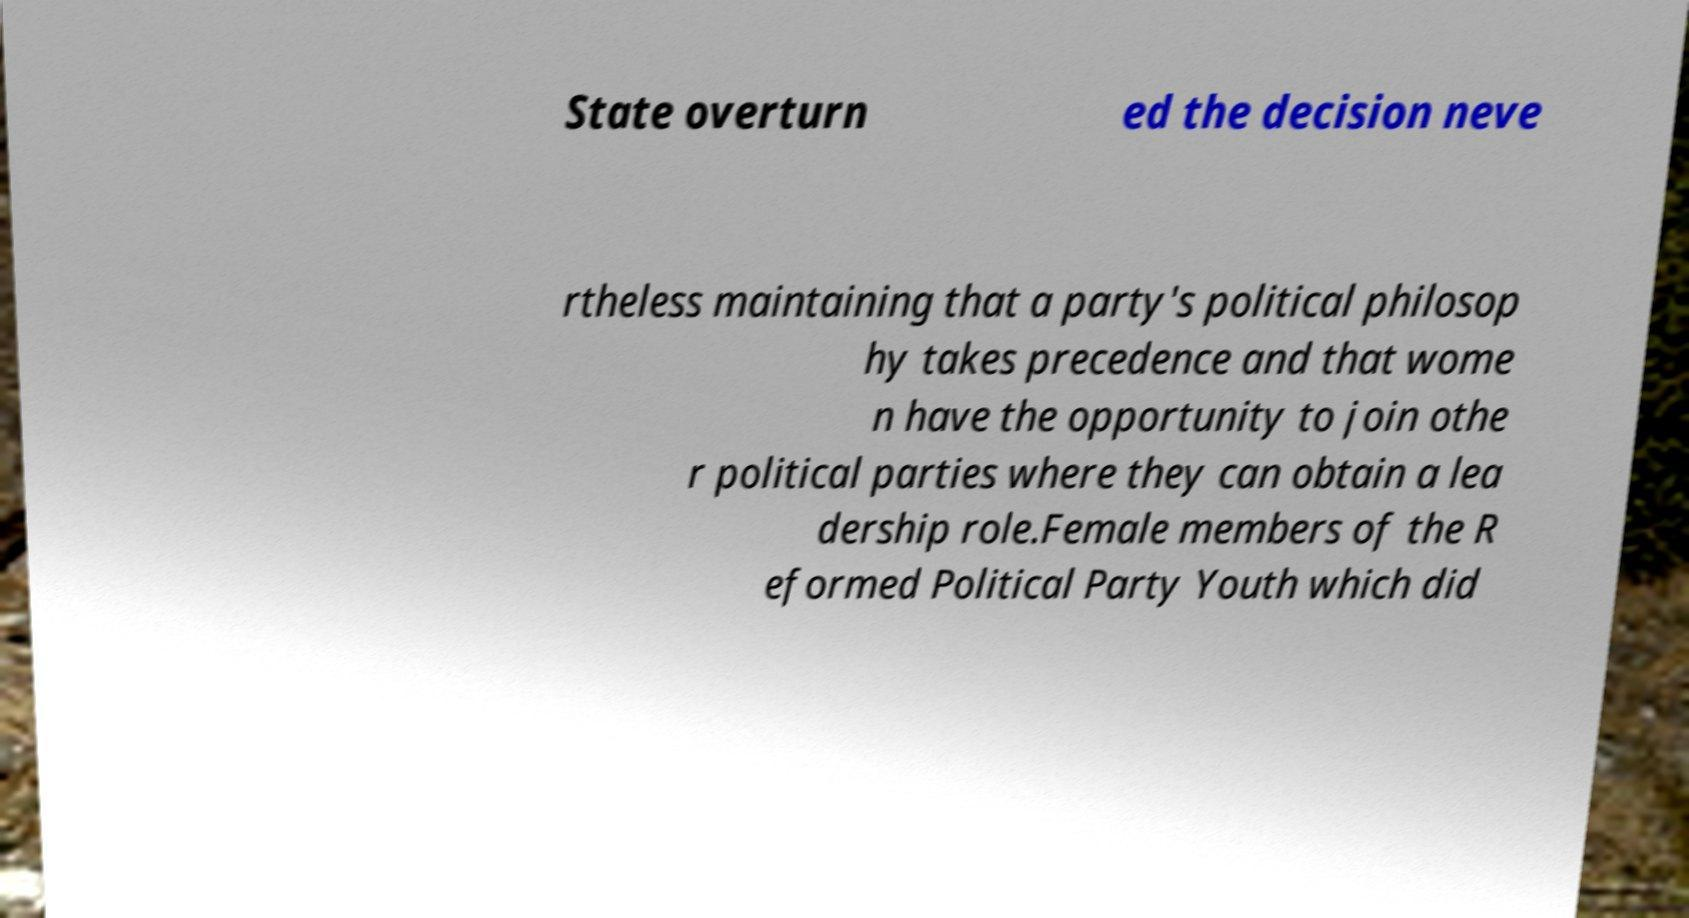What messages or text are displayed in this image? I need them in a readable, typed format. State overturn ed the decision neve rtheless maintaining that a party's political philosop hy takes precedence and that wome n have the opportunity to join othe r political parties where they can obtain a lea dership role.Female members of the R eformed Political Party Youth which did 